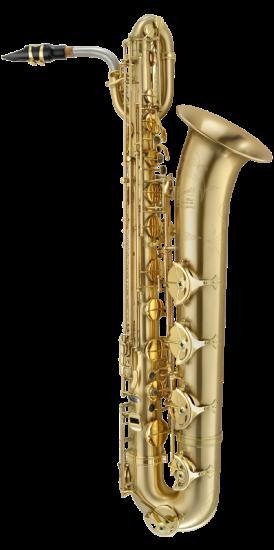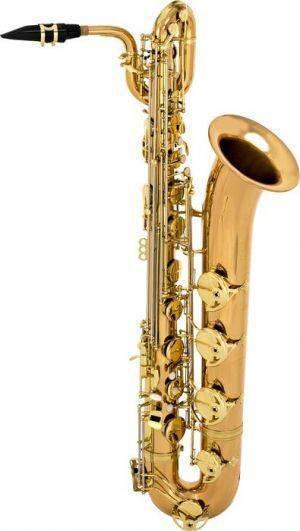The first image is the image on the left, the second image is the image on the right. Given the left and right images, does the statement "There is a soprano saxophone labeled." hold true? Answer yes or no. No. The first image is the image on the left, the second image is the image on the right. Considering the images on both sides, is "Neither of the images in the pair show more than three saxophones." valid? Answer yes or no. Yes. 